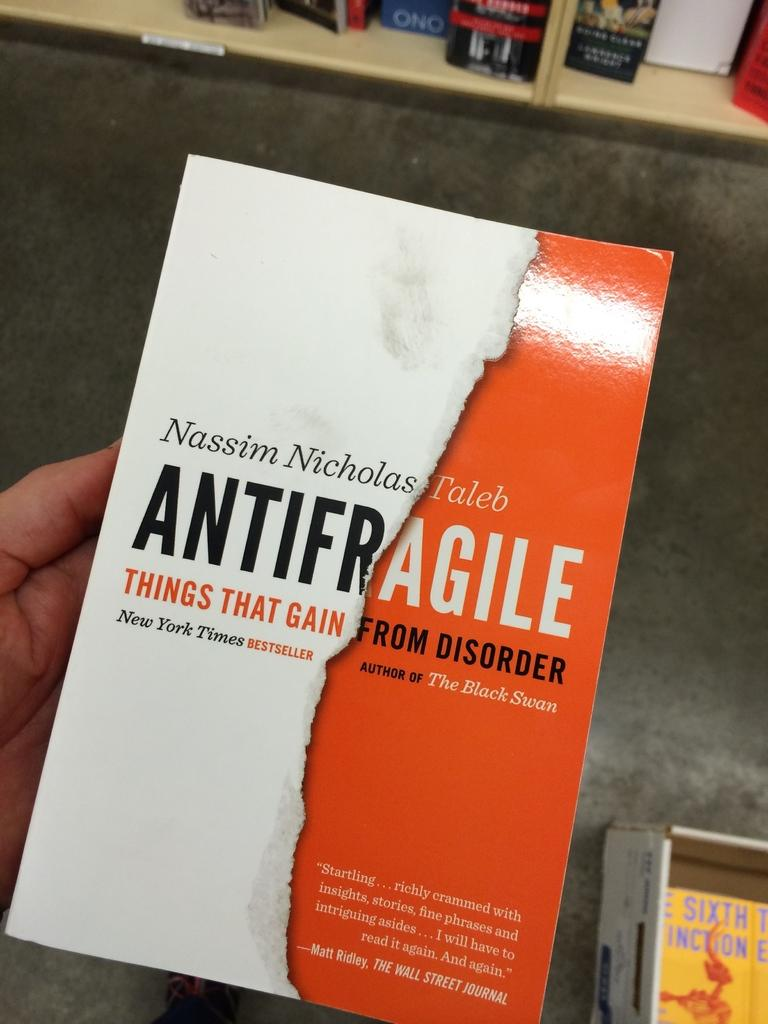<image>
Write a terse but informative summary of the picture. Person holding a book named Antifragile by Nassim Nicholas Taleb. 